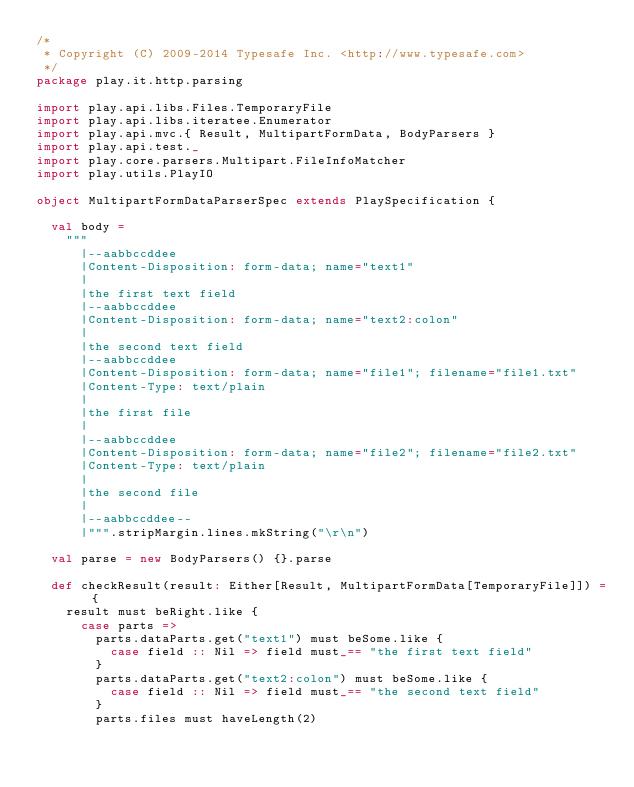Convert code to text. <code><loc_0><loc_0><loc_500><loc_500><_Scala_>/*
 * Copyright (C) 2009-2014 Typesafe Inc. <http://www.typesafe.com>
 */
package play.it.http.parsing

import play.api.libs.Files.TemporaryFile
import play.api.libs.iteratee.Enumerator
import play.api.mvc.{ Result, MultipartFormData, BodyParsers }
import play.api.test._
import play.core.parsers.Multipart.FileInfoMatcher
import play.utils.PlayIO

object MultipartFormDataParserSpec extends PlaySpecification {

  val body =
    """
      |--aabbccddee
      |Content-Disposition: form-data; name="text1"
      |
      |the first text field
      |--aabbccddee
      |Content-Disposition: form-data; name="text2:colon"
      |
      |the second text field
      |--aabbccddee
      |Content-Disposition: form-data; name="file1"; filename="file1.txt"
      |Content-Type: text/plain
      |
      |the first file
      |
      |--aabbccddee
      |Content-Disposition: form-data; name="file2"; filename="file2.txt"
      |Content-Type: text/plain
      |
      |the second file
      |
      |--aabbccddee--
      |""".stripMargin.lines.mkString("\r\n")

  val parse = new BodyParsers() {}.parse

  def checkResult(result: Either[Result, MultipartFormData[TemporaryFile]]) = {
    result must beRight.like {
      case parts =>
        parts.dataParts.get("text1") must beSome.like {
          case field :: Nil => field must_== "the first text field"
        }
        parts.dataParts.get("text2:colon") must beSome.like {
          case field :: Nil => field must_== "the second text field"
        }
        parts.files must haveLength(2)</code> 